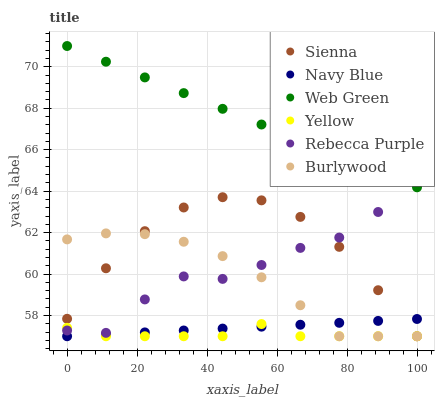Does Yellow have the minimum area under the curve?
Answer yes or no. Yes. Does Web Green have the maximum area under the curve?
Answer yes or no. Yes. Does Navy Blue have the minimum area under the curve?
Answer yes or no. No. Does Navy Blue have the maximum area under the curve?
Answer yes or no. No. Is Navy Blue the smoothest?
Answer yes or no. Yes. Is Rebecca Purple the roughest?
Answer yes or no. Yes. Is Yellow the smoothest?
Answer yes or no. No. Is Yellow the roughest?
Answer yes or no. No. Does Burlywood have the lowest value?
Answer yes or no. Yes. Does Web Green have the lowest value?
Answer yes or no. No. Does Web Green have the highest value?
Answer yes or no. Yes. Does Navy Blue have the highest value?
Answer yes or no. No. Is Yellow less than Web Green?
Answer yes or no. Yes. Is Web Green greater than Sienna?
Answer yes or no. Yes. Does Yellow intersect Burlywood?
Answer yes or no. Yes. Is Yellow less than Burlywood?
Answer yes or no. No. Is Yellow greater than Burlywood?
Answer yes or no. No. Does Yellow intersect Web Green?
Answer yes or no. No. 